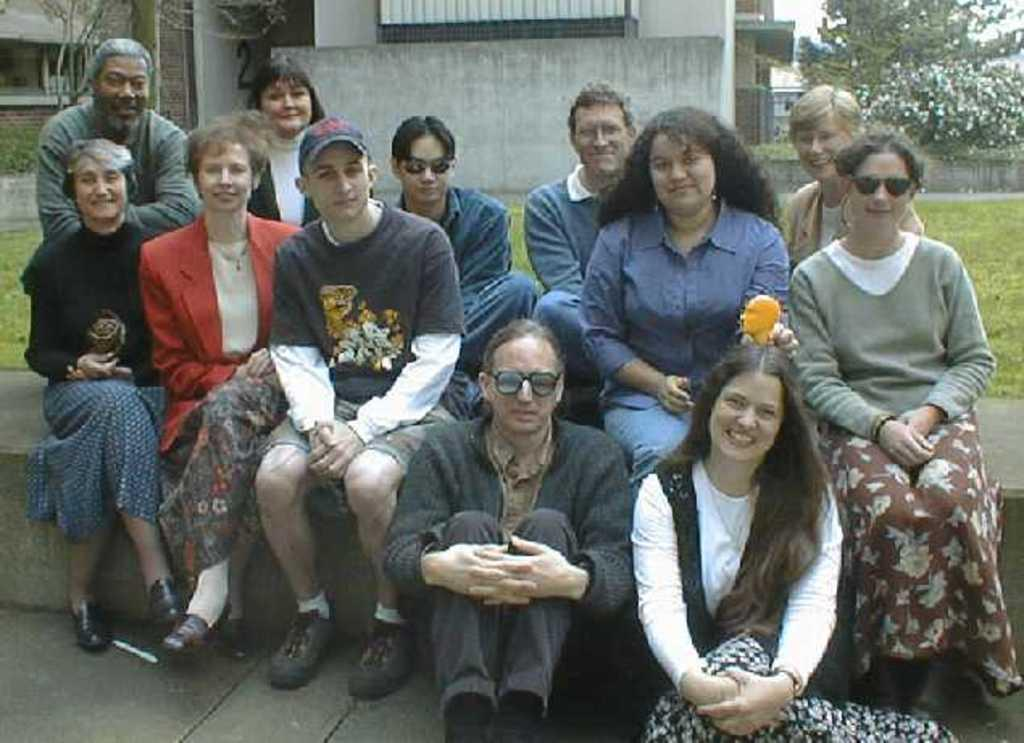What can be seen in the foreground of the image? There are people sitting in the foreground of the image. What is visible in the background of the image? There are houses, trees, and grass in the background of the image. What type of surface is visible at the bottom of the image? There is a floor visible at the bottom of the image. What type of education is being taught in the image? There is no indication of any educational activity in the image. What type of stew is being prepared in the image? There is no stew or cooking activity present in the image. 